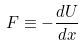Convert formula to latex. <formula><loc_0><loc_0><loc_500><loc_500>F \equiv - \frac { d U } { d x }</formula> 